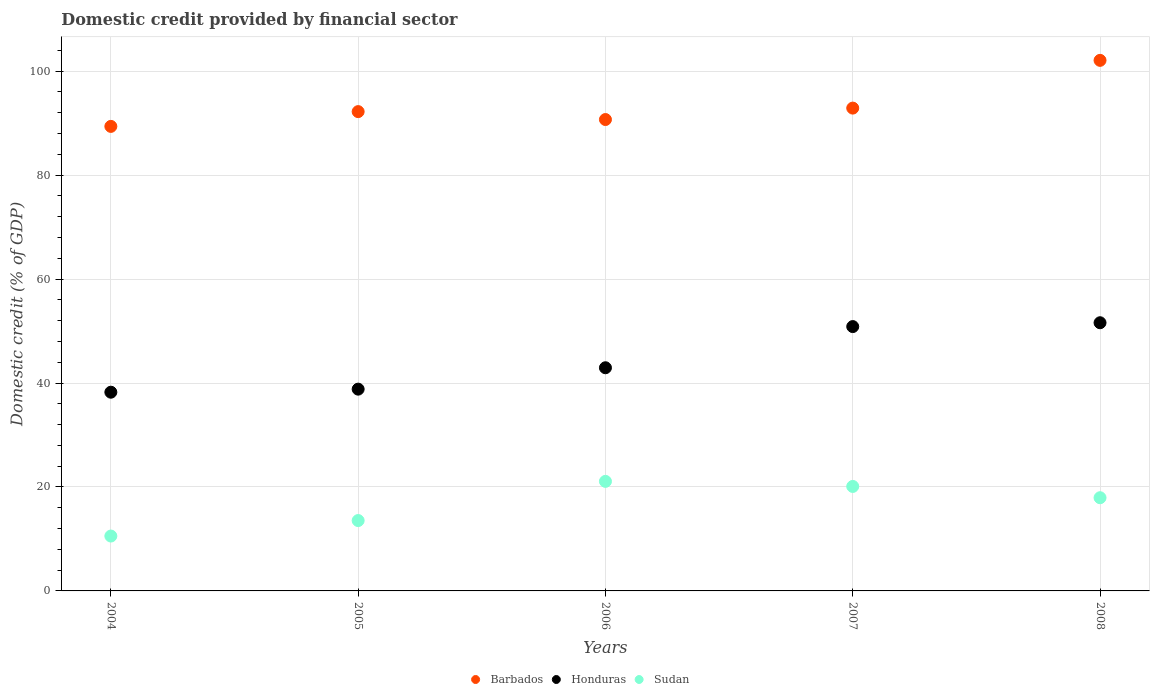What is the domestic credit in Barbados in 2008?
Make the answer very short. 102.07. Across all years, what is the maximum domestic credit in Sudan?
Offer a terse response. 21.08. Across all years, what is the minimum domestic credit in Honduras?
Give a very brief answer. 38.23. In which year was the domestic credit in Sudan minimum?
Your answer should be compact. 2004. What is the total domestic credit in Sudan in the graph?
Your response must be concise. 83.2. What is the difference between the domestic credit in Honduras in 2004 and that in 2005?
Keep it short and to the point. -0.59. What is the difference between the domestic credit in Sudan in 2006 and the domestic credit in Barbados in 2004?
Your answer should be compact. -68.29. What is the average domestic credit in Honduras per year?
Ensure brevity in your answer.  44.49. In the year 2008, what is the difference between the domestic credit in Honduras and domestic credit in Barbados?
Keep it short and to the point. -50.48. In how many years, is the domestic credit in Barbados greater than 92 %?
Give a very brief answer. 3. What is the ratio of the domestic credit in Sudan in 2006 to that in 2008?
Make the answer very short. 1.18. What is the difference between the highest and the second highest domestic credit in Sudan?
Your response must be concise. 0.97. What is the difference between the highest and the lowest domestic credit in Honduras?
Give a very brief answer. 13.36. In how many years, is the domestic credit in Honduras greater than the average domestic credit in Honduras taken over all years?
Make the answer very short. 2. Is it the case that in every year, the sum of the domestic credit in Honduras and domestic credit in Barbados  is greater than the domestic credit in Sudan?
Your answer should be very brief. Yes. Does the domestic credit in Barbados monotonically increase over the years?
Offer a terse response. No. Is the domestic credit in Sudan strictly greater than the domestic credit in Honduras over the years?
Offer a very short reply. No. How many dotlines are there?
Offer a terse response. 3. Are the values on the major ticks of Y-axis written in scientific E-notation?
Keep it short and to the point. No. Does the graph contain any zero values?
Your answer should be compact. No. Does the graph contain grids?
Provide a short and direct response. Yes. How many legend labels are there?
Provide a succinct answer. 3. How are the legend labels stacked?
Give a very brief answer. Horizontal. What is the title of the graph?
Ensure brevity in your answer.  Domestic credit provided by financial sector. Does "Australia" appear as one of the legend labels in the graph?
Your answer should be compact. No. What is the label or title of the X-axis?
Offer a very short reply. Years. What is the label or title of the Y-axis?
Your answer should be very brief. Domestic credit (% of GDP). What is the Domestic credit (% of GDP) of Barbados in 2004?
Offer a terse response. 89.37. What is the Domestic credit (% of GDP) of Honduras in 2004?
Keep it short and to the point. 38.23. What is the Domestic credit (% of GDP) in Sudan in 2004?
Offer a terse response. 10.56. What is the Domestic credit (% of GDP) in Barbados in 2005?
Provide a succinct answer. 92.21. What is the Domestic credit (% of GDP) of Honduras in 2005?
Your answer should be compact. 38.82. What is the Domestic credit (% of GDP) in Sudan in 2005?
Your response must be concise. 13.54. What is the Domestic credit (% of GDP) in Barbados in 2006?
Ensure brevity in your answer.  90.69. What is the Domestic credit (% of GDP) of Honduras in 2006?
Make the answer very short. 42.93. What is the Domestic credit (% of GDP) in Sudan in 2006?
Give a very brief answer. 21.08. What is the Domestic credit (% of GDP) in Barbados in 2007?
Your answer should be compact. 92.89. What is the Domestic credit (% of GDP) in Honduras in 2007?
Offer a very short reply. 50.86. What is the Domestic credit (% of GDP) in Sudan in 2007?
Offer a terse response. 20.1. What is the Domestic credit (% of GDP) of Barbados in 2008?
Your answer should be very brief. 102.07. What is the Domestic credit (% of GDP) of Honduras in 2008?
Ensure brevity in your answer.  51.59. What is the Domestic credit (% of GDP) in Sudan in 2008?
Offer a very short reply. 17.93. Across all years, what is the maximum Domestic credit (% of GDP) of Barbados?
Provide a short and direct response. 102.07. Across all years, what is the maximum Domestic credit (% of GDP) in Honduras?
Provide a short and direct response. 51.59. Across all years, what is the maximum Domestic credit (% of GDP) in Sudan?
Your response must be concise. 21.08. Across all years, what is the minimum Domestic credit (% of GDP) of Barbados?
Keep it short and to the point. 89.37. Across all years, what is the minimum Domestic credit (% of GDP) in Honduras?
Provide a short and direct response. 38.23. Across all years, what is the minimum Domestic credit (% of GDP) of Sudan?
Your answer should be compact. 10.56. What is the total Domestic credit (% of GDP) of Barbados in the graph?
Ensure brevity in your answer.  467.23. What is the total Domestic credit (% of GDP) in Honduras in the graph?
Keep it short and to the point. 222.43. What is the total Domestic credit (% of GDP) in Sudan in the graph?
Offer a terse response. 83.2. What is the difference between the Domestic credit (% of GDP) of Barbados in 2004 and that in 2005?
Give a very brief answer. -2.84. What is the difference between the Domestic credit (% of GDP) of Honduras in 2004 and that in 2005?
Make the answer very short. -0.59. What is the difference between the Domestic credit (% of GDP) of Sudan in 2004 and that in 2005?
Your answer should be compact. -2.98. What is the difference between the Domestic credit (% of GDP) of Barbados in 2004 and that in 2006?
Offer a terse response. -1.32. What is the difference between the Domestic credit (% of GDP) of Honduras in 2004 and that in 2006?
Provide a succinct answer. -4.7. What is the difference between the Domestic credit (% of GDP) of Sudan in 2004 and that in 2006?
Keep it short and to the point. -10.52. What is the difference between the Domestic credit (% of GDP) in Barbados in 2004 and that in 2007?
Make the answer very short. -3.52. What is the difference between the Domestic credit (% of GDP) of Honduras in 2004 and that in 2007?
Your answer should be very brief. -12.62. What is the difference between the Domestic credit (% of GDP) in Sudan in 2004 and that in 2007?
Provide a short and direct response. -9.54. What is the difference between the Domestic credit (% of GDP) in Barbados in 2004 and that in 2008?
Offer a very short reply. -12.7. What is the difference between the Domestic credit (% of GDP) in Honduras in 2004 and that in 2008?
Offer a very short reply. -13.36. What is the difference between the Domestic credit (% of GDP) of Sudan in 2004 and that in 2008?
Ensure brevity in your answer.  -7.37. What is the difference between the Domestic credit (% of GDP) in Barbados in 2005 and that in 2006?
Your response must be concise. 1.52. What is the difference between the Domestic credit (% of GDP) in Honduras in 2005 and that in 2006?
Your answer should be compact. -4.12. What is the difference between the Domestic credit (% of GDP) in Sudan in 2005 and that in 2006?
Give a very brief answer. -7.54. What is the difference between the Domestic credit (% of GDP) of Barbados in 2005 and that in 2007?
Offer a terse response. -0.68. What is the difference between the Domestic credit (% of GDP) of Honduras in 2005 and that in 2007?
Offer a terse response. -12.04. What is the difference between the Domestic credit (% of GDP) in Sudan in 2005 and that in 2007?
Offer a very short reply. -6.56. What is the difference between the Domestic credit (% of GDP) in Barbados in 2005 and that in 2008?
Make the answer very short. -9.86. What is the difference between the Domestic credit (% of GDP) in Honduras in 2005 and that in 2008?
Keep it short and to the point. -12.78. What is the difference between the Domestic credit (% of GDP) of Sudan in 2005 and that in 2008?
Offer a very short reply. -4.39. What is the difference between the Domestic credit (% of GDP) of Barbados in 2006 and that in 2007?
Ensure brevity in your answer.  -2.2. What is the difference between the Domestic credit (% of GDP) of Honduras in 2006 and that in 2007?
Give a very brief answer. -7.92. What is the difference between the Domestic credit (% of GDP) of Sudan in 2006 and that in 2007?
Keep it short and to the point. 0.97. What is the difference between the Domestic credit (% of GDP) of Barbados in 2006 and that in 2008?
Give a very brief answer. -11.38. What is the difference between the Domestic credit (% of GDP) in Honduras in 2006 and that in 2008?
Make the answer very short. -8.66. What is the difference between the Domestic credit (% of GDP) of Sudan in 2006 and that in 2008?
Provide a short and direct response. 3.14. What is the difference between the Domestic credit (% of GDP) in Barbados in 2007 and that in 2008?
Your response must be concise. -9.19. What is the difference between the Domestic credit (% of GDP) in Honduras in 2007 and that in 2008?
Ensure brevity in your answer.  -0.74. What is the difference between the Domestic credit (% of GDP) of Sudan in 2007 and that in 2008?
Provide a succinct answer. 2.17. What is the difference between the Domestic credit (% of GDP) of Barbados in 2004 and the Domestic credit (% of GDP) of Honduras in 2005?
Provide a succinct answer. 50.55. What is the difference between the Domestic credit (% of GDP) of Barbados in 2004 and the Domestic credit (% of GDP) of Sudan in 2005?
Provide a succinct answer. 75.83. What is the difference between the Domestic credit (% of GDP) of Honduras in 2004 and the Domestic credit (% of GDP) of Sudan in 2005?
Your response must be concise. 24.69. What is the difference between the Domestic credit (% of GDP) in Barbados in 2004 and the Domestic credit (% of GDP) in Honduras in 2006?
Give a very brief answer. 46.44. What is the difference between the Domestic credit (% of GDP) in Barbados in 2004 and the Domestic credit (% of GDP) in Sudan in 2006?
Provide a short and direct response. 68.29. What is the difference between the Domestic credit (% of GDP) of Honduras in 2004 and the Domestic credit (% of GDP) of Sudan in 2006?
Provide a succinct answer. 17.16. What is the difference between the Domestic credit (% of GDP) in Barbados in 2004 and the Domestic credit (% of GDP) in Honduras in 2007?
Give a very brief answer. 38.51. What is the difference between the Domestic credit (% of GDP) of Barbados in 2004 and the Domestic credit (% of GDP) of Sudan in 2007?
Make the answer very short. 69.27. What is the difference between the Domestic credit (% of GDP) of Honduras in 2004 and the Domestic credit (% of GDP) of Sudan in 2007?
Provide a short and direct response. 18.13. What is the difference between the Domestic credit (% of GDP) of Barbados in 2004 and the Domestic credit (% of GDP) of Honduras in 2008?
Make the answer very short. 37.77. What is the difference between the Domestic credit (% of GDP) in Barbados in 2004 and the Domestic credit (% of GDP) in Sudan in 2008?
Provide a short and direct response. 71.44. What is the difference between the Domestic credit (% of GDP) in Honduras in 2004 and the Domestic credit (% of GDP) in Sudan in 2008?
Offer a very short reply. 20.3. What is the difference between the Domestic credit (% of GDP) of Barbados in 2005 and the Domestic credit (% of GDP) of Honduras in 2006?
Offer a terse response. 49.28. What is the difference between the Domestic credit (% of GDP) of Barbados in 2005 and the Domestic credit (% of GDP) of Sudan in 2006?
Your response must be concise. 71.14. What is the difference between the Domestic credit (% of GDP) of Honduras in 2005 and the Domestic credit (% of GDP) of Sudan in 2006?
Keep it short and to the point. 17.74. What is the difference between the Domestic credit (% of GDP) in Barbados in 2005 and the Domestic credit (% of GDP) in Honduras in 2007?
Your answer should be very brief. 41.36. What is the difference between the Domestic credit (% of GDP) of Barbados in 2005 and the Domestic credit (% of GDP) of Sudan in 2007?
Provide a succinct answer. 72.11. What is the difference between the Domestic credit (% of GDP) in Honduras in 2005 and the Domestic credit (% of GDP) in Sudan in 2007?
Your answer should be very brief. 18.72. What is the difference between the Domestic credit (% of GDP) of Barbados in 2005 and the Domestic credit (% of GDP) of Honduras in 2008?
Your answer should be very brief. 40.62. What is the difference between the Domestic credit (% of GDP) of Barbados in 2005 and the Domestic credit (% of GDP) of Sudan in 2008?
Provide a succinct answer. 74.28. What is the difference between the Domestic credit (% of GDP) of Honduras in 2005 and the Domestic credit (% of GDP) of Sudan in 2008?
Provide a short and direct response. 20.89. What is the difference between the Domestic credit (% of GDP) in Barbados in 2006 and the Domestic credit (% of GDP) in Honduras in 2007?
Make the answer very short. 39.83. What is the difference between the Domestic credit (% of GDP) of Barbados in 2006 and the Domestic credit (% of GDP) of Sudan in 2007?
Offer a terse response. 70.59. What is the difference between the Domestic credit (% of GDP) in Honduras in 2006 and the Domestic credit (% of GDP) in Sudan in 2007?
Offer a very short reply. 22.83. What is the difference between the Domestic credit (% of GDP) in Barbados in 2006 and the Domestic credit (% of GDP) in Honduras in 2008?
Keep it short and to the point. 39.09. What is the difference between the Domestic credit (% of GDP) of Barbados in 2006 and the Domestic credit (% of GDP) of Sudan in 2008?
Your answer should be very brief. 72.76. What is the difference between the Domestic credit (% of GDP) in Honduras in 2006 and the Domestic credit (% of GDP) in Sudan in 2008?
Provide a succinct answer. 25. What is the difference between the Domestic credit (% of GDP) in Barbados in 2007 and the Domestic credit (% of GDP) in Honduras in 2008?
Offer a terse response. 41.29. What is the difference between the Domestic credit (% of GDP) of Barbados in 2007 and the Domestic credit (% of GDP) of Sudan in 2008?
Provide a short and direct response. 74.96. What is the difference between the Domestic credit (% of GDP) of Honduras in 2007 and the Domestic credit (% of GDP) of Sudan in 2008?
Make the answer very short. 32.92. What is the average Domestic credit (% of GDP) of Barbados per year?
Give a very brief answer. 93.45. What is the average Domestic credit (% of GDP) of Honduras per year?
Give a very brief answer. 44.49. What is the average Domestic credit (% of GDP) in Sudan per year?
Make the answer very short. 16.64. In the year 2004, what is the difference between the Domestic credit (% of GDP) in Barbados and Domestic credit (% of GDP) in Honduras?
Keep it short and to the point. 51.14. In the year 2004, what is the difference between the Domestic credit (% of GDP) in Barbados and Domestic credit (% of GDP) in Sudan?
Ensure brevity in your answer.  78.81. In the year 2004, what is the difference between the Domestic credit (% of GDP) in Honduras and Domestic credit (% of GDP) in Sudan?
Provide a succinct answer. 27.67. In the year 2005, what is the difference between the Domestic credit (% of GDP) of Barbados and Domestic credit (% of GDP) of Honduras?
Make the answer very short. 53.39. In the year 2005, what is the difference between the Domestic credit (% of GDP) of Barbados and Domestic credit (% of GDP) of Sudan?
Give a very brief answer. 78.67. In the year 2005, what is the difference between the Domestic credit (% of GDP) in Honduras and Domestic credit (% of GDP) in Sudan?
Provide a short and direct response. 25.28. In the year 2006, what is the difference between the Domestic credit (% of GDP) of Barbados and Domestic credit (% of GDP) of Honduras?
Ensure brevity in your answer.  47.76. In the year 2006, what is the difference between the Domestic credit (% of GDP) in Barbados and Domestic credit (% of GDP) in Sudan?
Provide a short and direct response. 69.61. In the year 2006, what is the difference between the Domestic credit (% of GDP) in Honduras and Domestic credit (% of GDP) in Sudan?
Provide a short and direct response. 21.86. In the year 2007, what is the difference between the Domestic credit (% of GDP) in Barbados and Domestic credit (% of GDP) in Honduras?
Ensure brevity in your answer.  42.03. In the year 2007, what is the difference between the Domestic credit (% of GDP) of Barbados and Domestic credit (% of GDP) of Sudan?
Offer a terse response. 72.79. In the year 2007, what is the difference between the Domestic credit (% of GDP) of Honduras and Domestic credit (% of GDP) of Sudan?
Your answer should be compact. 30.75. In the year 2008, what is the difference between the Domestic credit (% of GDP) of Barbados and Domestic credit (% of GDP) of Honduras?
Provide a succinct answer. 50.48. In the year 2008, what is the difference between the Domestic credit (% of GDP) in Barbados and Domestic credit (% of GDP) in Sudan?
Your response must be concise. 84.14. In the year 2008, what is the difference between the Domestic credit (% of GDP) in Honduras and Domestic credit (% of GDP) in Sudan?
Provide a succinct answer. 33.66. What is the ratio of the Domestic credit (% of GDP) of Barbados in 2004 to that in 2005?
Your answer should be very brief. 0.97. What is the ratio of the Domestic credit (% of GDP) in Honduras in 2004 to that in 2005?
Give a very brief answer. 0.98. What is the ratio of the Domestic credit (% of GDP) of Sudan in 2004 to that in 2005?
Your answer should be compact. 0.78. What is the ratio of the Domestic credit (% of GDP) of Barbados in 2004 to that in 2006?
Make the answer very short. 0.99. What is the ratio of the Domestic credit (% of GDP) of Honduras in 2004 to that in 2006?
Offer a very short reply. 0.89. What is the ratio of the Domestic credit (% of GDP) in Sudan in 2004 to that in 2006?
Keep it short and to the point. 0.5. What is the ratio of the Domestic credit (% of GDP) of Barbados in 2004 to that in 2007?
Your answer should be compact. 0.96. What is the ratio of the Domestic credit (% of GDP) of Honduras in 2004 to that in 2007?
Offer a very short reply. 0.75. What is the ratio of the Domestic credit (% of GDP) in Sudan in 2004 to that in 2007?
Provide a succinct answer. 0.53. What is the ratio of the Domestic credit (% of GDP) in Barbados in 2004 to that in 2008?
Provide a short and direct response. 0.88. What is the ratio of the Domestic credit (% of GDP) of Honduras in 2004 to that in 2008?
Provide a short and direct response. 0.74. What is the ratio of the Domestic credit (% of GDP) in Sudan in 2004 to that in 2008?
Offer a terse response. 0.59. What is the ratio of the Domestic credit (% of GDP) in Barbados in 2005 to that in 2006?
Give a very brief answer. 1.02. What is the ratio of the Domestic credit (% of GDP) in Honduras in 2005 to that in 2006?
Your response must be concise. 0.9. What is the ratio of the Domestic credit (% of GDP) in Sudan in 2005 to that in 2006?
Provide a succinct answer. 0.64. What is the ratio of the Domestic credit (% of GDP) of Honduras in 2005 to that in 2007?
Provide a succinct answer. 0.76. What is the ratio of the Domestic credit (% of GDP) of Sudan in 2005 to that in 2007?
Make the answer very short. 0.67. What is the ratio of the Domestic credit (% of GDP) in Barbados in 2005 to that in 2008?
Provide a succinct answer. 0.9. What is the ratio of the Domestic credit (% of GDP) of Honduras in 2005 to that in 2008?
Your answer should be very brief. 0.75. What is the ratio of the Domestic credit (% of GDP) in Sudan in 2005 to that in 2008?
Keep it short and to the point. 0.76. What is the ratio of the Domestic credit (% of GDP) in Barbados in 2006 to that in 2007?
Your answer should be very brief. 0.98. What is the ratio of the Domestic credit (% of GDP) in Honduras in 2006 to that in 2007?
Make the answer very short. 0.84. What is the ratio of the Domestic credit (% of GDP) of Sudan in 2006 to that in 2007?
Ensure brevity in your answer.  1.05. What is the ratio of the Domestic credit (% of GDP) of Barbados in 2006 to that in 2008?
Make the answer very short. 0.89. What is the ratio of the Domestic credit (% of GDP) of Honduras in 2006 to that in 2008?
Keep it short and to the point. 0.83. What is the ratio of the Domestic credit (% of GDP) in Sudan in 2006 to that in 2008?
Offer a terse response. 1.18. What is the ratio of the Domestic credit (% of GDP) of Barbados in 2007 to that in 2008?
Your answer should be very brief. 0.91. What is the ratio of the Domestic credit (% of GDP) in Honduras in 2007 to that in 2008?
Provide a succinct answer. 0.99. What is the ratio of the Domestic credit (% of GDP) of Sudan in 2007 to that in 2008?
Your response must be concise. 1.12. What is the difference between the highest and the second highest Domestic credit (% of GDP) of Barbados?
Provide a short and direct response. 9.19. What is the difference between the highest and the second highest Domestic credit (% of GDP) of Honduras?
Provide a short and direct response. 0.74. What is the difference between the highest and the second highest Domestic credit (% of GDP) in Sudan?
Give a very brief answer. 0.97. What is the difference between the highest and the lowest Domestic credit (% of GDP) in Barbados?
Give a very brief answer. 12.7. What is the difference between the highest and the lowest Domestic credit (% of GDP) in Honduras?
Ensure brevity in your answer.  13.36. What is the difference between the highest and the lowest Domestic credit (% of GDP) in Sudan?
Offer a terse response. 10.52. 